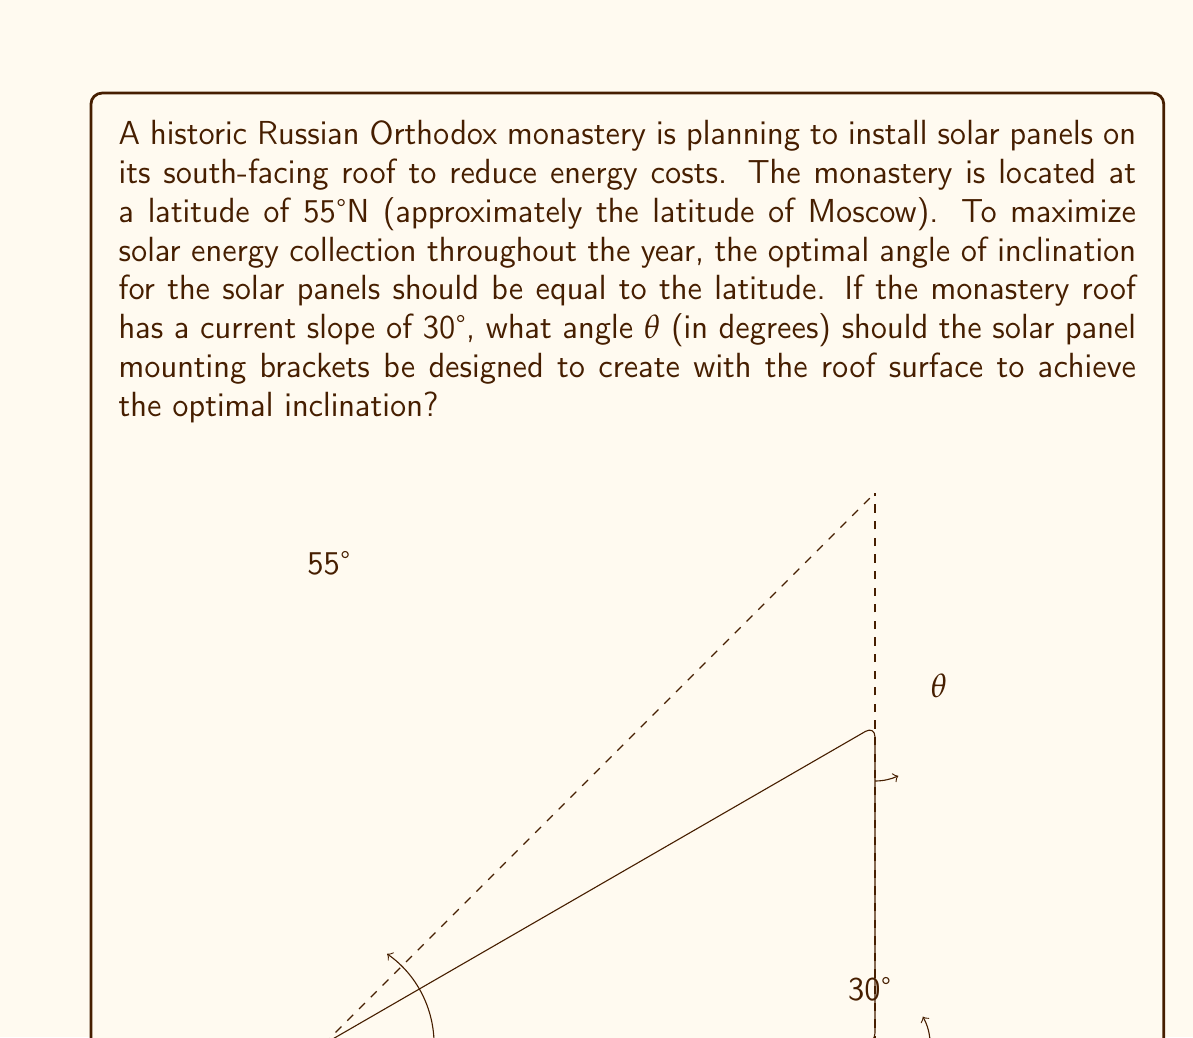Provide a solution to this math problem. Let's approach this step-by-step:

1) The optimal angle of inclination for the solar panels is equal to the latitude, which is 55°.

2) The current roof slope is 30°.

3) We need to find the angle θ that the mounting brackets should make with the roof surface to achieve a total inclination of 55°.

4) We can set up an equation based on the angles in the triangle:

   $$30° + θ = 55°$$

5) Solving for θ:

   $$θ = 55° - 30°$$
   $$θ = 25°$$

6) Therefore, the mounting brackets should be designed to create a 25° angle with the roof surface.

This solution uses basic angle addition and subtraction. The key is recognizing that the optimal panel angle (55°) is the sum of the existing roof angle (30°) and the needed bracket angle (θ).
Answer: $25°$ 